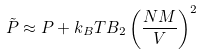<formula> <loc_0><loc_0><loc_500><loc_500>\tilde { P } \approx P + k _ { B } T B _ { 2 } \left ( \frac { N M } { V } \right ) ^ { 2 }</formula> 